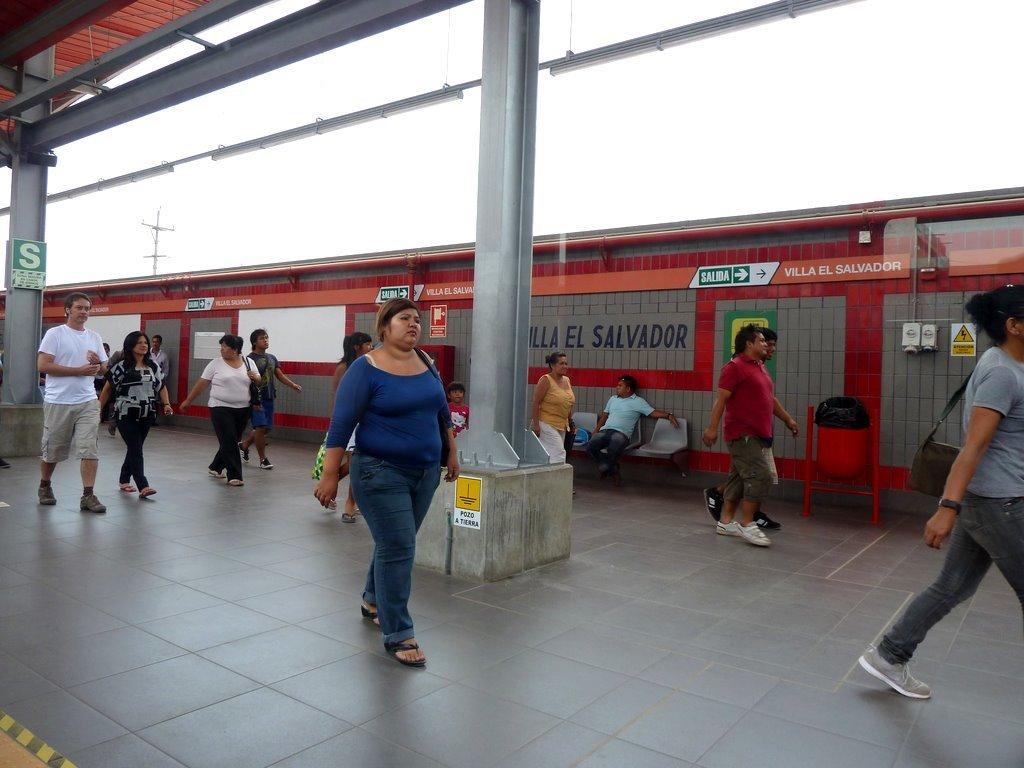Who is the main subject in the image? There is a woman in the image. What is the woman doing in the image? The woman is walking on the floor. What is the woman wearing in the image? The woman is wearing a blue t-shirt. Who else is present in the image? There is a man sitting on a chair in the image, and there are other persons walking on the floor. What type of class is being taught in the image? There is no indication of a class being taught in the image. 